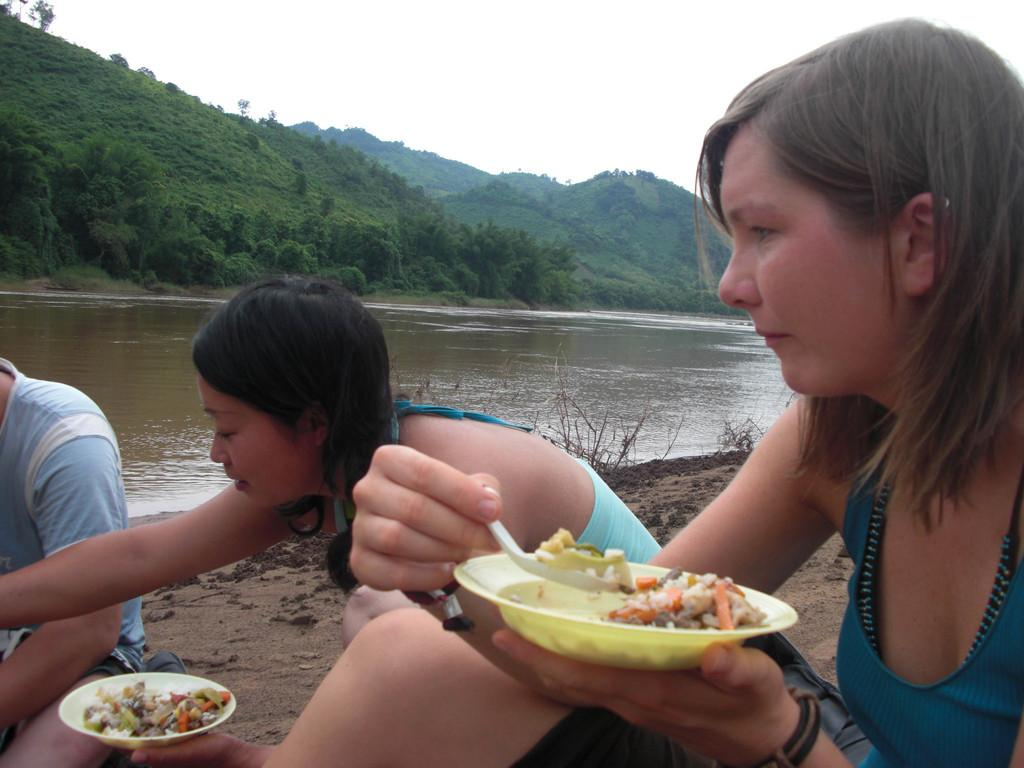How many people are sitting in the image? There are three persons sitting in the image. What are two of the persons holding? Two persons are holding plates. What natural elements can be seen in the image? There is water, trees, hills, and the sky visible in the image. What type of band is performing on the hill in the image? There is no band performing on the hill in the image; it only shows three persons sitting and holding plates. 